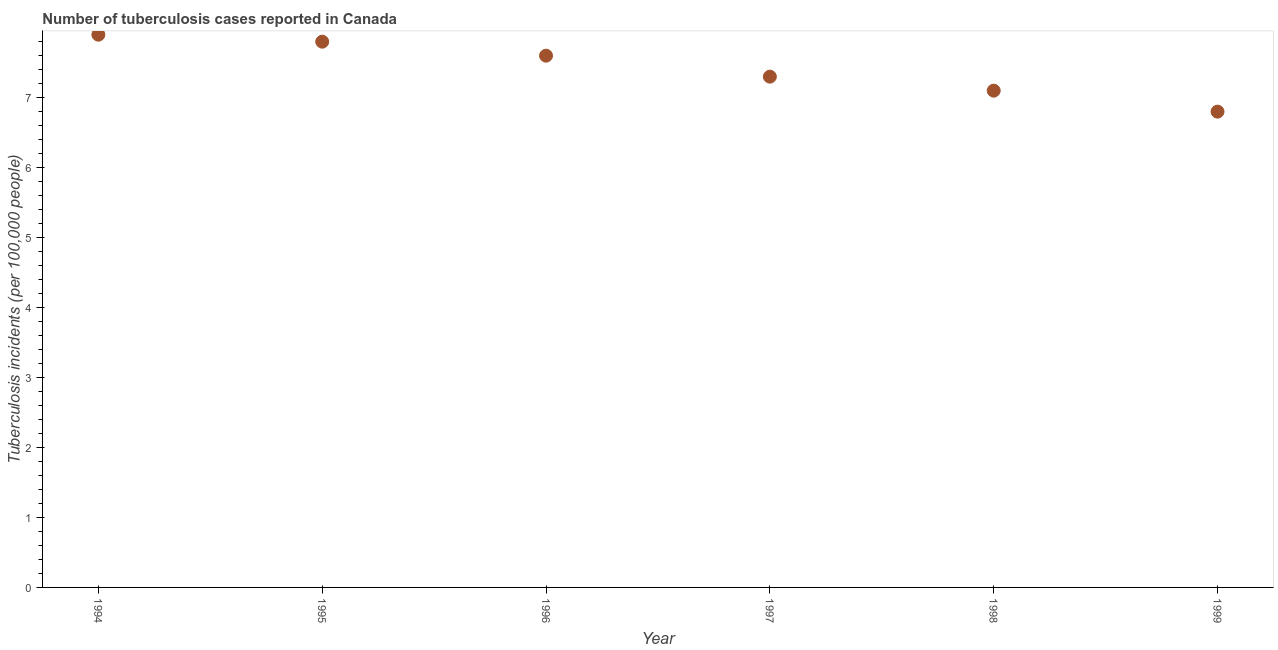Across all years, what is the minimum number of tuberculosis incidents?
Your response must be concise. 6.8. In which year was the number of tuberculosis incidents maximum?
Keep it short and to the point. 1994. What is the sum of the number of tuberculosis incidents?
Your answer should be very brief. 44.5. What is the difference between the number of tuberculosis incidents in 1995 and 1998?
Your answer should be compact. 0.7. What is the average number of tuberculosis incidents per year?
Keep it short and to the point. 7.42. What is the median number of tuberculosis incidents?
Provide a succinct answer. 7.45. What is the ratio of the number of tuberculosis incidents in 1996 to that in 1997?
Keep it short and to the point. 1.04. Is the number of tuberculosis incidents in 1995 less than that in 1997?
Provide a succinct answer. No. What is the difference between the highest and the second highest number of tuberculosis incidents?
Provide a succinct answer. 0.1. Is the sum of the number of tuberculosis incidents in 1994 and 1995 greater than the maximum number of tuberculosis incidents across all years?
Make the answer very short. Yes. What is the difference between the highest and the lowest number of tuberculosis incidents?
Your response must be concise. 1.1. In how many years, is the number of tuberculosis incidents greater than the average number of tuberculosis incidents taken over all years?
Provide a succinct answer. 3. Does the number of tuberculosis incidents monotonically increase over the years?
Provide a short and direct response. No. How many years are there in the graph?
Your answer should be compact. 6. What is the difference between two consecutive major ticks on the Y-axis?
Your answer should be very brief. 1. What is the title of the graph?
Provide a short and direct response. Number of tuberculosis cases reported in Canada. What is the label or title of the Y-axis?
Your answer should be very brief. Tuberculosis incidents (per 100,0 people). What is the Tuberculosis incidents (per 100,000 people) in 1994?
Your answer should be compact. 7.9. What is the Tuberculosis incidents (per 100,000 people) in 1995?
Provide a short and direct response. 7.8. What is the Tuberculosis incidents (per 100,000 people) in 1998?
Offer a terse response. 7.1. What is the difference between the Tuberculosis incidents (per 100,000 people) in 1994 and 1995?
Your answer should be compact. 0.1. What is the difference between the Tuberculosis incidents (per 100,000 people) in 1994 and 1996?
Your response must be concise. 0.3. What is the difference between the Tuberculosis incidents (per 100,000 people) in 1994 and 1997?
Provide a succinct answer. 0.6. What is the difference between the Tuberculosis incidents (per 100,000 people) in 1994 and 1998?
Offer a very short reply. 0.8. What is the difference between the Tuberculosis incidents (per 100,000 people) in 1995 and 1996?
Your answer should be very brief. 0.2. What is the difference between the Tuberculosis incidents (per 100,000 people) in 1995 and 1997?
Your response must be concise. 0.5. What is the difference between the Tuberculosis incidents (per 100,000 people) in 1996 and 1998?
Your response must be concise. 0.5. What is the difference between the Tuberculosis incidents (per 100,000 people) in 1996 and 1999?
Make the answer very short. 0.8. What is the difference between the Tuberculosis incidents (per 100,000 people) in 1998 and 1999?
Your answer should be very brief. 0.3. What is the ratio of the Tuberculosis incidents (per 100,000 people) in 1994 to that in 1995?
Provide a short and direct response. 1.01. What is the ratio of the Tuberculosis incidents (per 100,000 people) in 1994 to that in 1996?
Provide a succinct answer. 1.04. What is the ratio of the Tuberculosis incidents (per 100,000 people) in 1994 to that in 1997?
Your response must be concise. 1.08. What is the ratio of the Tuberculosis incidents (per 100,000 people) in 1994 to that in 1998?
Offer a very short reply. 1.11. What is the ratio of the Tuberculosis incidents (per 100,000 people) in 1994 to that in 1999?
Your answer should be compact. 1.16. What is the ratio of the Tuberculosis incidents (per 100,000 people) in 1995 to that in 1997?
Keep it short and to the point. 1.07. What is the ratio of the Tuberculosis incidents (per 100,000 people) in 1995 to that in 1998?
Your response must be concise. 1.1. What is the ratio of the Tuberculosis incidents (per 100,000 people) in 1995 to that in 1999?
Make the answer very short. 1.15. What is the ratio of the Tuberculosis incidents (per 100,000 people) in 1996 to that in 1997?
Offer a very short reply. 1.04. What is the ratio of the Tuberculosis incidents (per 100,000 people) in 1996 to that in 1998?
Give a very brief answer. 1.07. What is the ratio of the Tuberculosis incidents (per 100,000 people) in 1996 to that in 1999?
Give a very brief answer. 1.12. What is the ratio of the Tuberculosis incidents (per 100,000 people) in 1997 to that in 1998?
Offer a terse response. 1.03. What is the ratio of the Tuberculosis incidents (per 100,000 people) in 1997 to that in 1999?
Keep it short and to the point. 1.07. What is the ratio of the Tuberculosis incidents (per 100,000 people) in 1998 to that in 1999?
Your answer should be very brief. 1.04. 